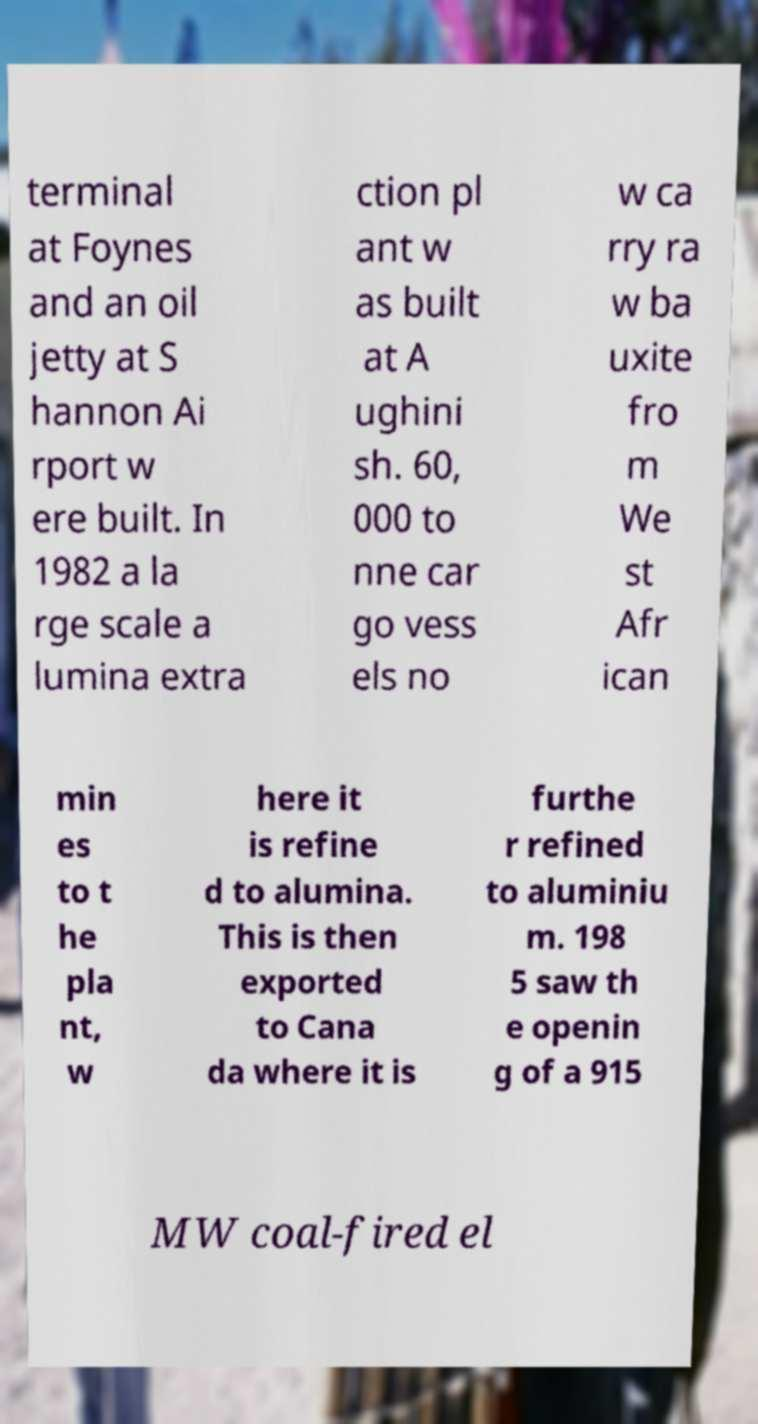Could you assist in decoding the text presented in this image and type it out clearly? terminal at Foynes and an oil jetty at S hannon Ai rport w ere built. In 1982 a la rge scale a lumina extra ction pl ant w as built at A ughini sh. 60, 000 to nne car go vess els no w ca rry ra w ba uxite fro m We st Afr ican min es to t he pla nt, w here it is refine d to alumina. This is then exported to Cana da where it is furthe r refined to aluminiu m. 198 5 saw th e openin g of a 915 MW coal-fired el 